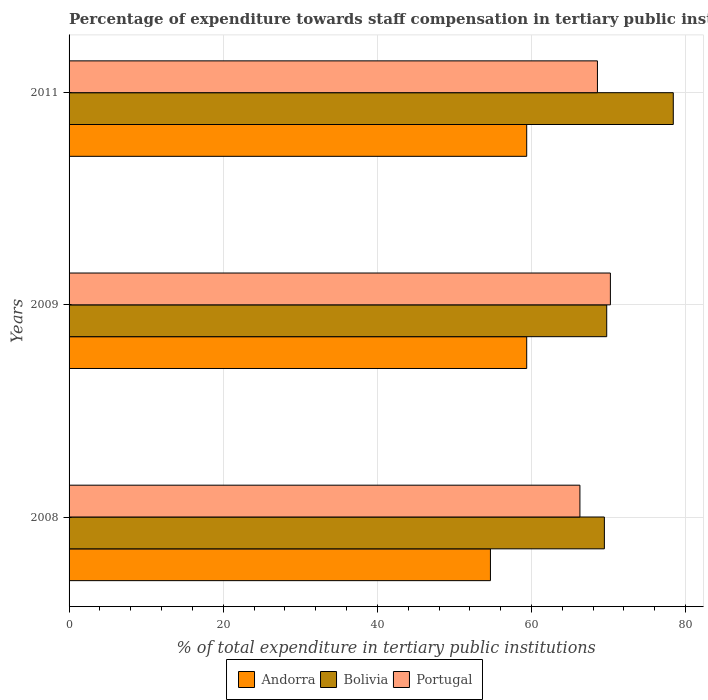How many groups of bars are there?
Your answer should be compact. 3. Are the number of bars per tick equal to the number of legend labels?
Offer a terse response. Yes. Are the number of bars on each tick of the Y-axis equal?
Ensure brevity in your answer.  Yes. How many bars are there on the 3rd tick from the top?
Your response must be concise. 3. In how many cases, is the number of bars for a given year not equal to the number of legend labels?
Your answer should be compact. 0. What is the percentage of expenditure towards staff compensation in Andorra in 2009?
Give a very brief answer. 59.38. Across all years, what is the maximum percentage of expenditure towards staff compensation in Andorra?
Your answer should be compact. 59.38. Across all years, what is the minimum percentage of expenditure towards staff compensation in Bolivia?
Ensure brevity in your answer.  69.46. What is the total percentage of expenditure towards staff compensation in Bolivia in the graph?
Offer a very short reply. 217.61. What is the difference between the percentage of expenditure towards staff compensation in Andorra in 2008 and that in 2011?
Your response must be concise. -4.71. What is the difference between the percentage of expenditure towards staff compensation in Bolivia in 2009 and the percentage of expenditure towards staff compensation in Andorra in 2011?
Give a very brief answer. 10.38. What is the average percentage of expenditure towards staff compensation in Bolivia per year?
Your answer should be compact. 72.54. In the year 2011, what is the difference between the percentage of expenditure towards staff compensation in Bolivia and percentage of expenditure towards staff compensation in Andorra?
Provide a succinct answer. 19.02. In how many years, is the percentage of expenditure towards staff compensation in Andorra greater than 64 %?
Keep it short and to the point. 0. What is the ratio of the percentage of expenditure towards staff compensation in Portugal in 2008 to that in 2009?
Make the answer very short. 0.94. Is the percentage of expenditure towards staff compensation in Andorra in 2009 less than that in 2011?
Ensure brevity in your answer.  No. Is the difference between the percentage of expenditure towards staff compensation in Bolivia in 2008 and 2009 greater than the difference between the percentage of expenditure towards staff compensation in Andorra in 2008 and 2009?
Your response must be concise. Yes. What is the difference between the highest and the second highest percentage of expenditure towards staff compensation in Portugal?
Offer a very short reply. 1.68. What is the difference between the highest and the lowest percentage of expenditure towards staff compensation in Andorra?
Give a very brief answer. 4.71. In how many years, is the percentage of expenditure towards staff compensation in Bolivia greater than the average percentage of expenditure towards staff compensation in Bolivia taken over all years?
Provide a short and direct response. 1. Is the sum of the percentage of expenditure towards staff compensation in Andorra in 2008 and 2011 greater than the maximum percentage of expenditure towards staff compensation in Bolivia across all years?
Make the answer very short. Yes. What does the 1st bar from the top in 2009 represents?
Make the answer very short. Portugal. Is it the case that in every year, the sum of the percentage of expenditure towards staff compensation in Bolivia and percentage of expenditure towards staff compensation in Portugal is greater than the percentage of expenditure towards staff compensation in Andorra?
Your response must be concise. Yes. Are all the bars in the graph horizontal?
Make the answer very short. Yes. How many years are there in the graph?
Your response must be concise. 3. What is the difference between two consecutive major ticks on the X-axis?
Provide a short and direct response. 20. Where does the legend appear in the graph?
Provide a succinct answer. Bottom center. How many legend labels are there?
Your response must be concise. 3. What is the title of the graph?
Provide a succinct answer. Percentage of expenditure towards staff compensation in tertiary public institutions. Does "Middle East & North Africa (developing only)" appear as one of the legend labels in the graph?
Give a very brief answer. No. What is the label or title of the X-axis?
Ensure brevity in your answer.  % of total expenditure in tertiary public institutions. What is the label or title of the Y-axis?
Offer a terse response. Years. What is the % of total expenditure in tertiary public institutions in Andorra in 2008?
Offer a terse response. 54.67. What is the % of total expenditure in tertiary public institutions of Bolivia in 2008?
Provide a short and direct response. 69.46. What is the % of total expenditure in tertiary public institutions in Portugal in 2008?
Give a very brief answer. 66.28. What is the % of total expenditure in tertiary public institutions of Andorra in 2009?
Make the answer very short. 59.38. What is the % of total expenditure in tertiary public institutions of Bolivia in 2009?
Provide a short and direct response. 69.76. What is the % of total expenditure in tertiary public institutions of Portugal in 2009?
Make the answer very short. 70.24. What is the % of total expenditure in tertiary public institutions in Andorra in 2011?
Your answer should be compact. 59.38. What is the % of total expenditure in tertiary public institutions of Bolivia in 2011?
Your response must be concise. 78.4. What is the % of total expenditure in tertiary public institutions of Portugal in 2011?
Ensure brevity in your answer.  68.56. Across all years, what is the maximum % of total expenditure in tertiary public institutions in Andorra?
Your answer should be very brief. 59.38. Across all years, what is the maximum % of total expenditure in tertiary public institutions in Bolivia?
Ensure brevity in your answer.  78.4. Across all years, what is the maximum % of total expenditure in tertiary public institutions in Portugal?
Your response must be concise. 70.24. Across all years, what is the minimum % of total expenditure in tertiary public institutions of Andorra?
Ensure brevity in your answer.  54.67. Across all years, what is the minimum % of total expenditure in tertiary public institutions in Bolivia?
Ensure brevity in your answer.  69.46. Across all years, what is the minimum % of total expenditure in tertiary public institutions in Portugal?
Provide a short and direct response. 66.28. What is the total % of total expenditure in tertiary public institutions of Andorra in the graph?
Your response must be concise. 173.43. What is the total % of total expenditure in tertiary public institutions of Bolivia in the graph?
Make the answer very short. 217.61. What is the total % of total expenditure in tertiary public institutions of Portugal in the graph?
Provide a succinct answer. 205.07. What is the difference between the % of total expenditure in tertiary public institutions in Andorra in 2008 and that in 2009?
Keep it short and to the point. -4.71. What is the difference between the % of total expenditure in tertiary public institutions of Bolivia in 2008 and that in 2009?
Provide a short and direct response. -0.3. What is the difference between the % of total expenditure in tertiary public institutions of Portugal in 2008 and that in 2009?
Provide a short and direct response. -3.95. What is the difference between the % of total expenditure in tertiary public institutions in Andorra in 2008 and that in 2011?
Provide a short and direct response. -4.71. What is the difference between the % of total expenditure in tertiary public institutions of Bolivia in 2008 and that in 2011?
Give a very brief answer. -8.94. What is the difference between the % of total expenditure in tertiary public institutions of Portugal in 2008 and that in 2011?
Provide a short and direct response. -2.27. What is the difference between the % of total expenditure in tertiary public institutions in Andorra in 2009 and that in 2011?
Provide a succinct answer. 0. What is the difference between the % of total expenditure in tertiary public institutions in Bolivia in 2009 and that in 2011?
Ensure brevity in your answer.  -8.64. What is the difference between the % of total expenditure in tertiary public institutions of Portugal in 2009 and that in 2011?
Ensure brevity in your answer.  1.68. What is the difference between the % of total expenditure in tertiary public institutions of Andorra in 2008 and the % of total expenditure in tertiary public institutions of Bolivia in 2009?
Give a very brief answer. -15.09. What is the difference between the % of total expenditure in tertiary public institutions of Andorra in 2008 and the % of total expenditure in tertiary public institutions of Portugal in 2009?
Provide a short and direct response. -15.56. What is the difference between the % of total expenditure in tertiary public institutions in Bolivia in 2008 and the % of total expenditure in tertiary public institutions in Portugal in 2009?
Give a very brief answer. -0.78. What is the difference between the % of total expenditure in tertiary public institutions in Andorra in 2008 and the % of total expenditure in tertiary public institutions in Bolivia in 2011?
Keep it short and to the point. -23.72. What is the difference between the % of total expenditure in tertiary public institutions in Andorra in 2008 and the % of total expenditure in tertiary public institutions in Portugal in 2011?
Offer a very short reply. -13.88. What is the difference between the % of total expenditure in tertiary public institutions of Bolivia in 2008 and the % of total expenditure in tertiary public institutions of Portugal in 2011?
Offer a terse response. 0.9. What is the difference between the % of total expenditure in tertiary public institutions in Andorra in 2009 and the % of total expenditure in tertiary public institutions in Bolivia in 2011?
Keep it short and to the point. -19.02. What is the difference between the % of total expenditure in tertiary public institutions of Andorra in 2009 and the % of total expenditure in tertiary public institutions of Portugal in 2011?
Provide a short and direct response. -9.18. What is the difference between the % of total expenditure in tertiary public institutions in Bolivia in 2009 and the % of total expenditure in tertiary public institutions in Portugal in 2011?
Provide a short and direct response. 1.2. What is the average % of total expenditure in tertiary public institutions of Andorra per year?
Offer a terse response. 57.81. What is the average % of total expenditure in tertiary public institutions in Bolivia per year?
Offer a very short reply. 72.54. What is the average % of total expenditure in tertiary public institutions in Portugal per year?
Give a very brief answer. 68.36. In the year 2008, what is the difference between the % of total expenditure in tertiary public institutions in Andorra and % of total expenditure in tertiary public institutions in Bolivia?
Make the answer very short. -14.78. In the year 2008, what is the difference between the % of total expenditure in tertiary public institutions of Andorra and % of total expenditure in tertiary public institutions of Portugal?
Offer a very short reply. -11.61. In the year 2008, what is the difference between the % of total expenditure in tertiary public institutions of Bolivia and % of total expenditure in tertiary public institutions of Portugal?
Your answer should be compact. 3.17. In the year 2009, what is the difference between the % of total expenditure in tertiary public institutions in Andorra and % of total expenditure in tertiary public institutions in Bolivia?
Offer a very short reply. -10.38. In the year 2009, what is the difference between the % of total expenditure in tertiary public institutions of Andorra and % of total expenditure in tertiary public institutions of Portugal?
Your answer should be compact. -10.86. In the year 2009, what is the difference between the % of total expenditure in tertiary public institutions in Bolivia and % of total expenditure in tertiary public institutions in Portugal?
Provide a succinct answer. -0.48. In the year 2011, what is the difference between the % of total expenditure in tertiary public institutions of Andorra and % of total expenditure in tertiary public institutions of Bolivia?
Provide a short and direct response. -19.02. In the year 2011, what is the difference between the % of total expenditure in tertiary public institutions of Andorra and % of total expenditure in tertiary public institutions of Portugal?
Ensure brevity in your answer.  -9.18. In the year 2011, what is the difference between the % of total expenditure in tertiary public institutions in Bolivia and % of total expenditure in tertiary public institutions in Portugal?
Offer a very short reply. 9.84. What is the ratio of the % of total expenditure in tertiary public institutions in Andorra in 2008 to that in 2009?
Provide a succinct answer. 0.92. What is the ratio of the % of total expenditure in tertiary public institutions in Bolivia in 2008 to that in 2009?
Give a very brief answer. 1. What is the ratio of the % of total expenditure in tertiary public institutions of Portugal in 2008 to that in 2009?
Your answer should be compact. 0.94. What is the ratio of the % of total expenditure in tertiary public institutions of Andorra in 2008 to that in 2011?
Make the answer very short. 0.92. What is the ratio of the % of total expenditure in tertiary public institutions in Bolivia in 2008 to that in 2011?
Offer a terse response. 0.89. What is the ratio of the % of total expenditure in tertiary public institutions in Portugal in 2008 to that in 2011?
Keep it short and to the point. 0.97. What is the ratio of the % of total expenditure in tertiary public institutions in Andorra in 2009 to that in 2011?
Provide a short and direct response. 1. What is the ratio of the % of total expenditure in tertiary public institutions of Bolivia in 2009 to that in 2011?
Offer a terse response. 0.89. What is the ratio of the % of total expenditure in tertiary public institutions of Portugal in 2009 to that in 2011?
Provide a succinct answer. 1.02. What is the difference between the highest and the second highest % of total expenditure in tertiary public institutions of Bolivia?
Provide a short and direct response. 8.64. What is the difference between the highest and the second highest % of total expenditure in tertiary public institutions in Portugal?
Give a very brief answer. 1.68. What is the difference between the highest and the lowest % of total expenditure in tertiary public institutions of Andorra?
Offer a very short reply. 4.71. What is the difference between the highest and the lowest % of total expenditure in tertiary public institutions of Bolivia?
Offer a very short reply. 8.94. What is the difference between the highest and the lowest % of total expenditure in tertiary public institutions in Portugal?
Your response must be concise. 3.95. 